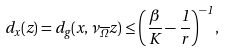Convert formula to latex. <formula><loc_0><loc_0><loc_500><loc_500>d _ { x } ( z ) = d _ { g } ( x , \nu _ { \overline { \Omega } } z ) \leq \left ( \frac { \beta } { K } - \frac { 1 } { r } \right ) ^ { - 1 } ,</formula> 